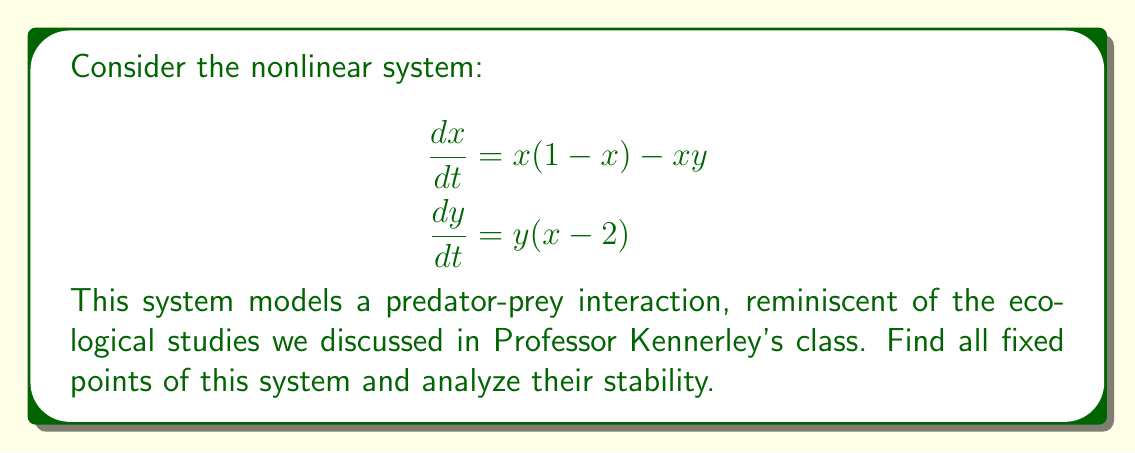Can you answer this question? 1. Find the fixed points:
   Set $\frac{dx}{dt} = 0$ and $\frac{dy}{dt} = 0$:
   
   $$\begin{aligned}
   x(1-x) - xy &= 0 \\
   y(x-2) &= 0
   \end{aligned}$$

   From the second equation, either $y=0$ or $x=2$.
   
   Case 1: If $y=0$, then $x(1-x) = 0$, so $x=0$ or $x=1$.
   Case 2: If $x=2$, then $2(1-2) - 2y = 0$, so $y = -\frac{1}{2}$.

   Fixed points: $(0,0)$, $(1,0)$, and $(2,-\frac{1}{2})$.

2. Analyze stability:
   Compute the Jacobian matrix:
   
   $$J = \begin{bmatrix}
   1-2x-y & -x \\
   y & x-2
   \end{bmatrix}$$

   a) For $(0,0)$:
      
      $$J_{(0,0)} = \begin{bmatrix}
      1 & 0 \\
      0 & -2
      \end{bmatrix}$$
      
      Eigenvalues: $\lambda_1 = 1$, $\lambda_2 = -2$
      This is a saddle point (unstable).

   b) For $(1,0)$:
      
      $$J_{(1,0)} = \begin{bmatrix}
      -1 & -1 \\
      0 & -1
      \end{bmatrix}$$
      
      Eigenvalues: $\lambda_1 = \lambda_2 = -1$
      This is a stable node.

   c) For $(2,-\frac{1}{2})$:
      
      $$J_{(2,-\frac{1}{2})} = \begin{bmatrix}
      -\frac{3}{2} & -2 \\
      -\frac{1}{2} & 0
      \end{bmatrix}$$
      
      Characteristic equation: $\lambda^2 + \frac{3}{2}\lambda + 1 = 0$
      Eigenvalues: $\lambda_{1,2} = -\frac{3}{4} \pm i\frac{\sqrt{7}}{4}$
      This is a stable spiral.
Answer: $(0,0)$: saddle point (unstable), $(1,0)$: stable node, $(2,-\frac{1}{2})$: stable spiral 